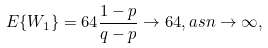<formula> <loc_0><loc_0><loc_500><loc_500>E \{ W _ { 1 } \} = 6 4 \frac { 1 - p } { q - p } \rightarrow 6 4 , a s n \rightarrow \infty ,</formula> 